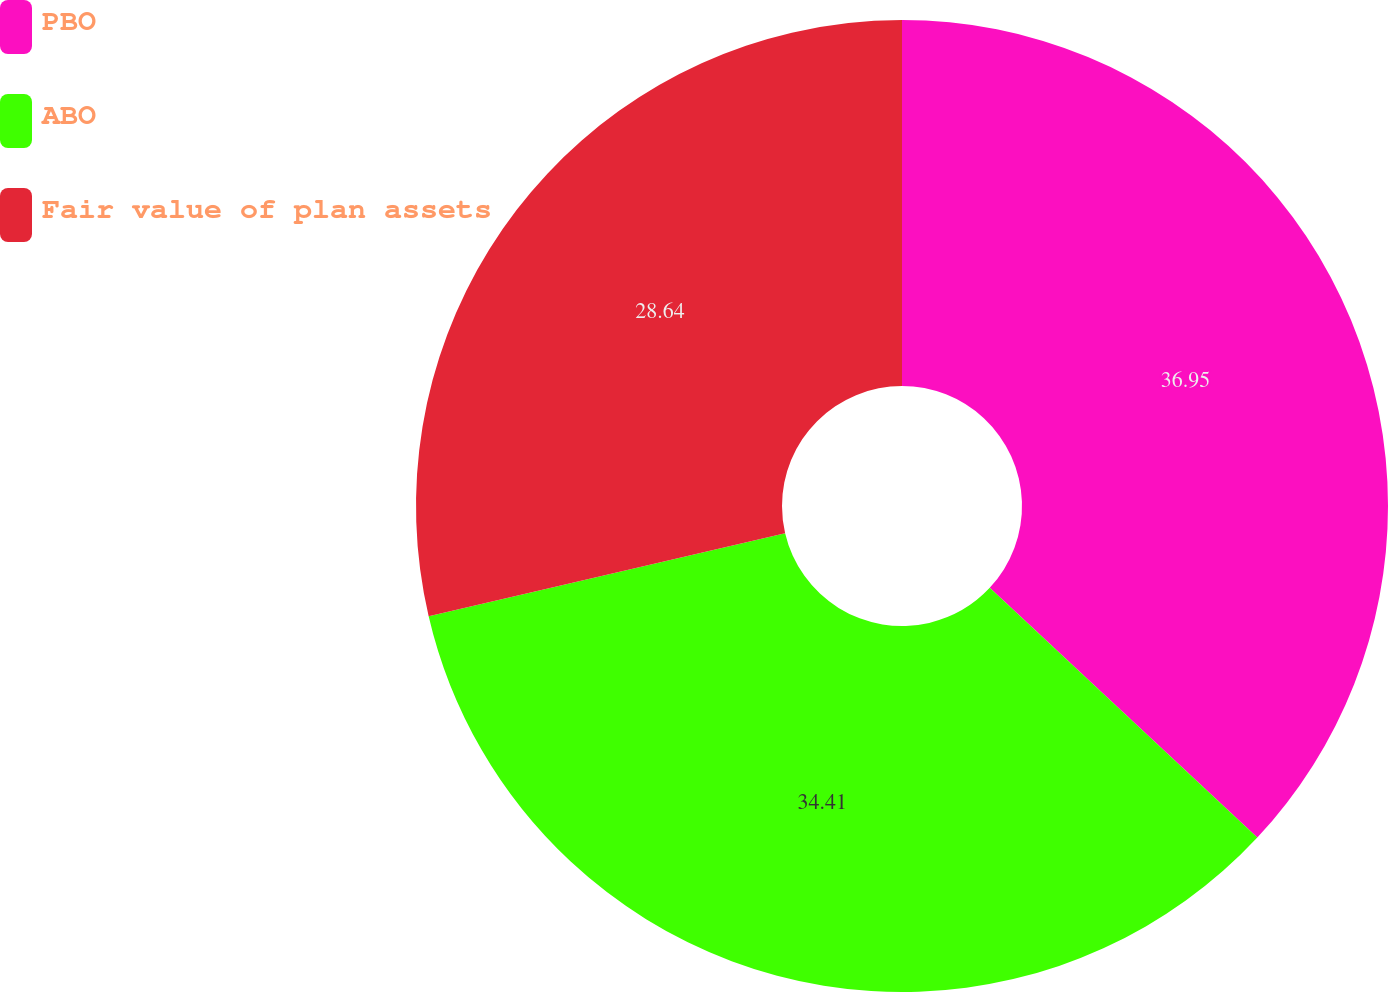Convert chart to OTSL. <chart><loc_0><loc_0><loc_500><loc_500><pie_chart><fcel>PBO<fcel>ABO<fcel>Fair value of plan assets<nl><fcel>36.95%<fcel>34.41%<fcel>28.64%<nl></chart> 